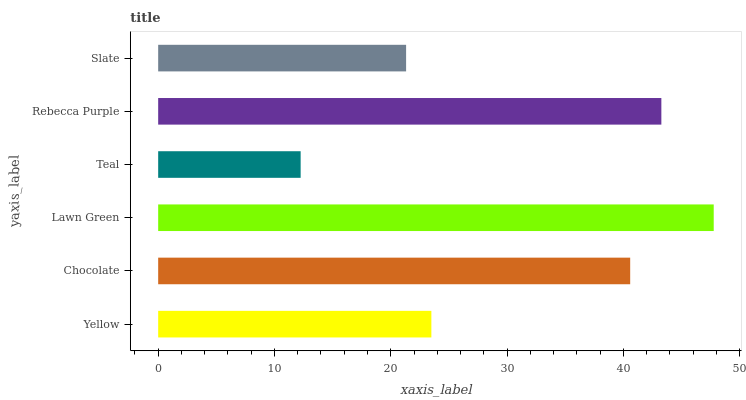Is Teal the minimum?
Answer yes or no. Yes. Is Lawn Green the maximum?
Answer yes or no. Yes. Is Chocolate the minimum?
Answer yes or no. No. Is Chocolate the maximum?
Answer yes or no. No. Is Chocolate greater than Yellow?
Answer yes or no. Yes. Is Yellow less than Chocolate?
Answer yes or no. Yes. Is Yellow greater than Chocolate?
Answer yes or no. No. Is Chocolate less than Yellow?
Answer yes or no. No. Is Chocolate the high median?
Answer yes or no. Yes. Is Yellow the low median?
Answer yes or no. Yes. Is Teal the high median?
Answer yes or no. No. Is Chocolate the low median?
Answer yes or no. No. 